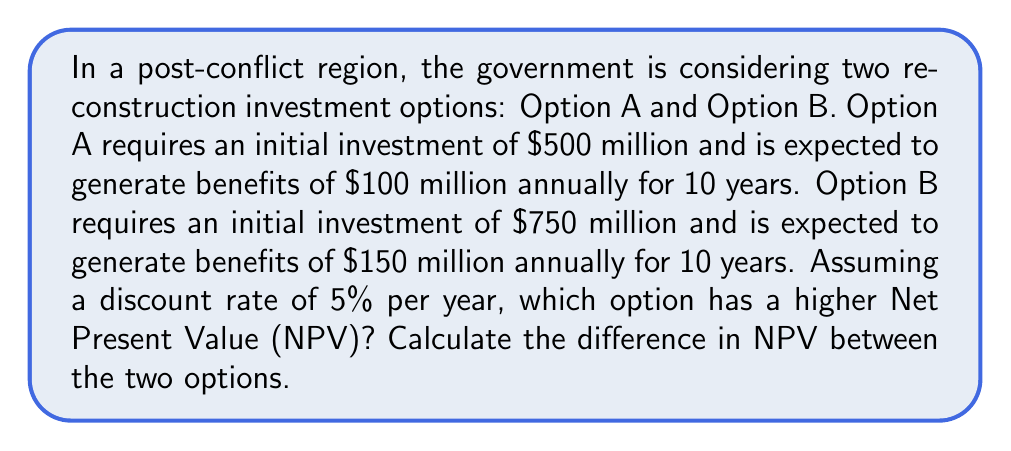Give your solution to this math problem. To solve this problem, we need to calculate the Net Present Value (NPV) for each option and compare them. The NPV is the difference between the present value of cash inflows and the present value of cash outflows over a period of time.

The formula for NPV is:

$$ NPV = -I + \sum_{t=1}^{n} \frac{CF_t}{(1+r)^t} $$

Where:
$I$ = Initial investment
$CF_t$ = Cash flow at time $t$
$r$ = Discount rate
$n$ = Number of periods

For Option A:
Initial investment ($I_A$) = $500 million
Annual benefit ($CF_A$) = $100 million
Discount rate ($r$) = 5% = 0.05
Number of periods ($n$) = 10 years

$$ NPV_A = -500 + \sum_{t=1}^{10} \frac{100}{(1+0.05)^t} $$

For Option B:
Initial investment ($I_B$) = $750 million
Annual benefit ($CF_B$) = $150 million
Discount rate ($r$) = 5% = 0.05
Number of periods ($n$) = 10 years

$$ NPV_B = -750 + \sum_{t=1}^{10} \frac{150}{(1+0.05)^t} $$

To calculate these NPVs, we can use the present value annuity factor (PVAF) formula:

$$ PVAF = \frac{1-\frac{1}{(1+r)^n}}{r} $$

For our case:
$$ PVAF = \frac{1-\frac{1}{(1+0.05)^{10}}}{0.05} \approx 7.7217 $$

Now we can calculate the NPVs:

$NPV_A = -500 + (100 \times 7.7217) = -500 + 772.17 = 272.17$ million

$NPV_B = -750 + (150 \times 7.7217) = -750 + 1158.26 = 408.26$ million

The difference in NPV is:
$NPV_B - NPV_A = 408.26 - 272.17 = 136.09$ million
Answer: Option B has a higher Net Present Value. The difference in NPV between Option B and Option A is $136.09 million. 